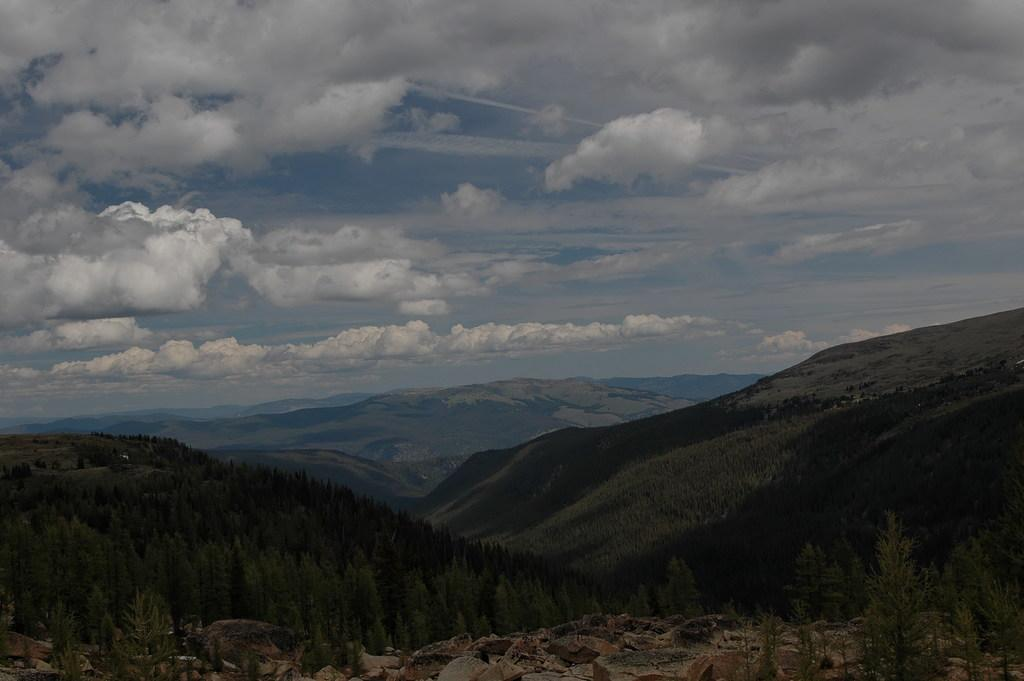What type of natural landscape is depicted in the image? The image features mountains. What other elements can be seen in the image? There are plants in the image. Can you see any men playing in the mountains in the image? There are no men or any indication of playing in the image; it only features mountains and plants. 